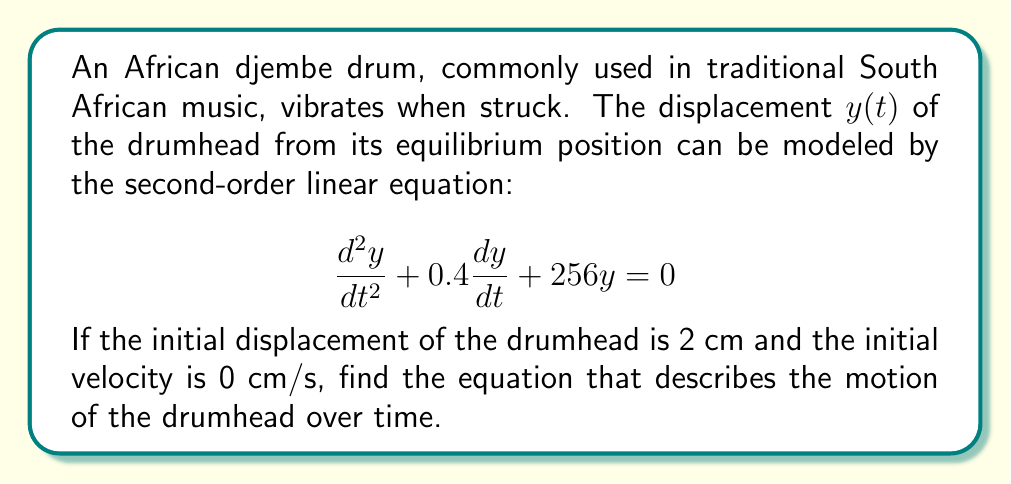Provide a solution to this math problem. To solve this problem, we'll follow these steps:

1) First, we identify the equation as a damped harmonic oscillator equation in the form:
   $$\frac{d^2y}{dt^2} + 2\beta\frac{dy}{dt} + \omega_0^2y = 0$$
   where $2\beta = 0.4$ and $\omega_0^2 = 256$.

2) We calculate $\beta = 0.2$ and $\omega_0 = 16$.

3) Next, we calculate the discriminant to determine the type of damping:
   $$\beta^2 - \omega_0^2 = 0.2^2 - 16^2 = 0.04 - 256 = -255.96 < 0$$
   Since it's negative, this is an underdamped system.

4) For an underdamped system, the general solution is:
   $$y(t) = e^{-\beta t}(A\cos(\omega t) + B\sin(\omega t))$$
   where $\omega = \sqrt{\omega_0^2 - \beta^2} = \sqrt{256 - 0.04} = \sqrt{255.96} \approx 15.9987$

5) We use the initial conditions to find A and B:
   - At $t=0$, $y(0) = 2$, so $A = 2$
   - The initial velocity is given by $y'(t) = -\beta e^{-\beta t}(A\cos(\omega t) + B\sin(\omega t)) + e^{-\beta t}(-A\omega\sin(\omega t) + B\omega\cos(\omega t))$
   - At $t=0$, $y'(0) = 0 = -0.2A + B\omega$, so $B = \frac{0.2A}{\omega} = \frac{0.4}{15.9987} \approx 0.025$

6) Therefore, the solution is:
   $$y(t) = e^{-0.2t}(2\cos(15.9987t) + 0.025\sin(15.9987t))$$
Answer: $$y(t) = e^{-0.2t}(2\cos(15.9987t) + 0.025\sin(15.9987t))$$ 